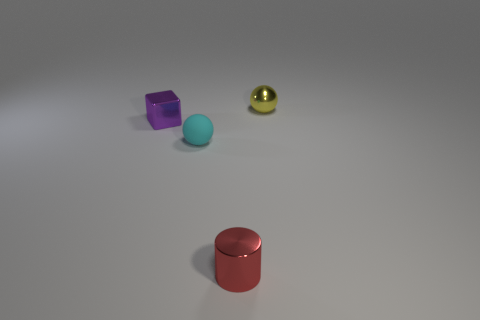What color is the small ball that is the same material as the cube?
Provide a short and direct response. Yellow. There is a small metal object that is on the right side of the cylinder; is its shape the same as the purple metallic thing that is behind the cyan matte thing?
Offer a terse response. No. How many shiny objects are tiny objects or large spheres?
Your answer should be very brief. 3. Is there anything else that has the same shape as the yellow object?
Provide a short and direct response. Yes. There is a tiny sphere in front of the metal block; what is its material?
Ensure brevity in your answer.  Rubber. Does the small sphere that is behind the purple shiny cube have the same material as the red object?
Give a very brief answer. Yes. How many objects are large cylinders or shiny things that are behind the small red object?
Your answer should be very brief. 2. There is a cyan rubber object that is the same shape as the tiny yellow metallic object; what is its size?
Make the answer very short. Small. Are there any other things that are the same size as the matte object?
Your response must be concise. Yes. Are there any small cyan matte spheres left of the small cylinder?
Your answer should be very brief. Yes. 